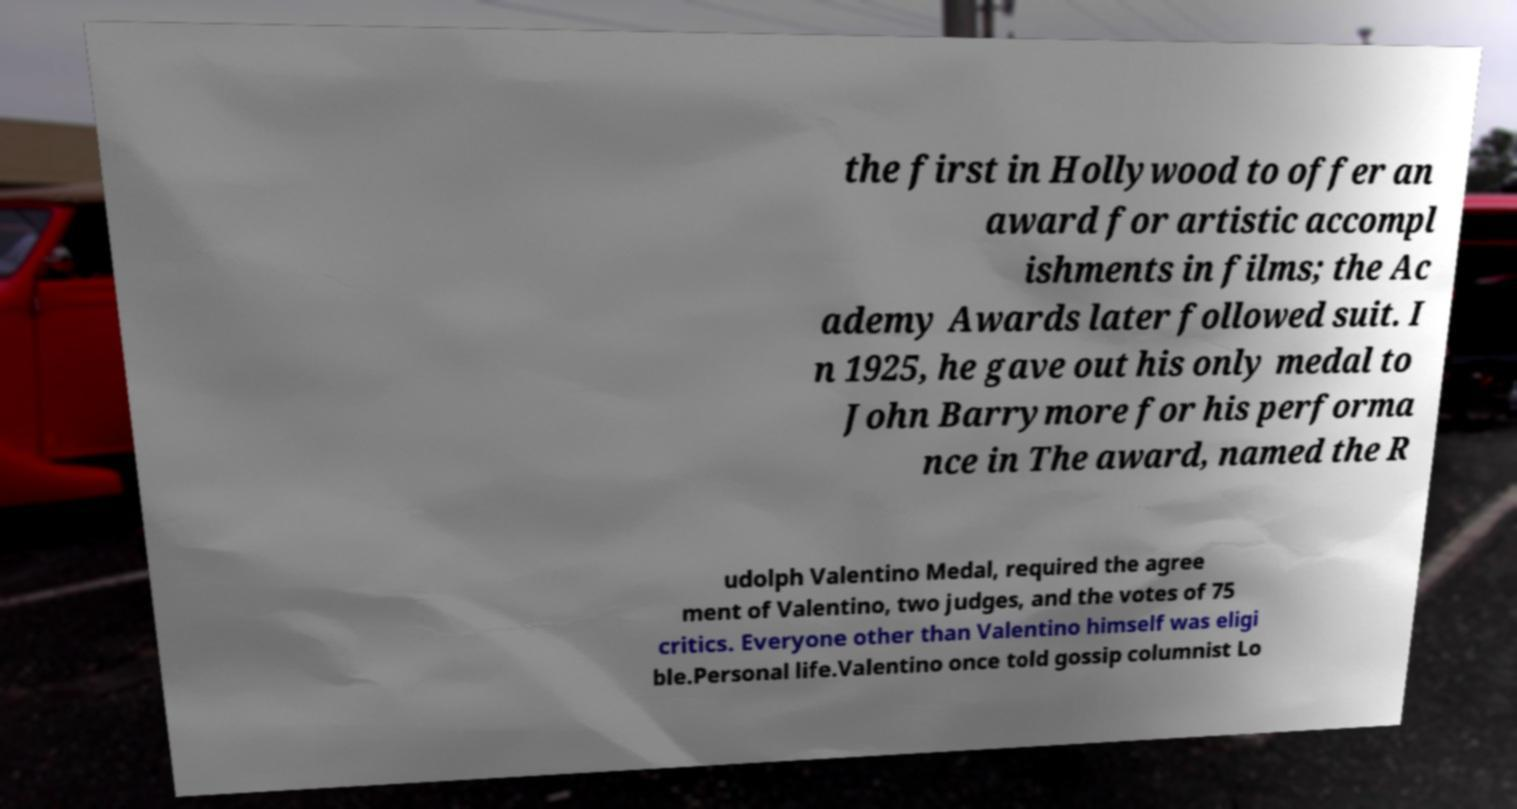Could you extract and type out the text from this image? the first in Hollywood to offer an award for artistic accompl ishments in films; the Ac ademy Awards later followed suit. I n 1925, he gave out his only medal to John Barrymore for his performa nce in The award, named the R udolph Valentino Medal, required the agree ment of Valentino, two judges, and the votes of 75 critics. Everyone other than Valentino himself was eligi ble.Personal life.Valentino once told gossip columnist Lo 